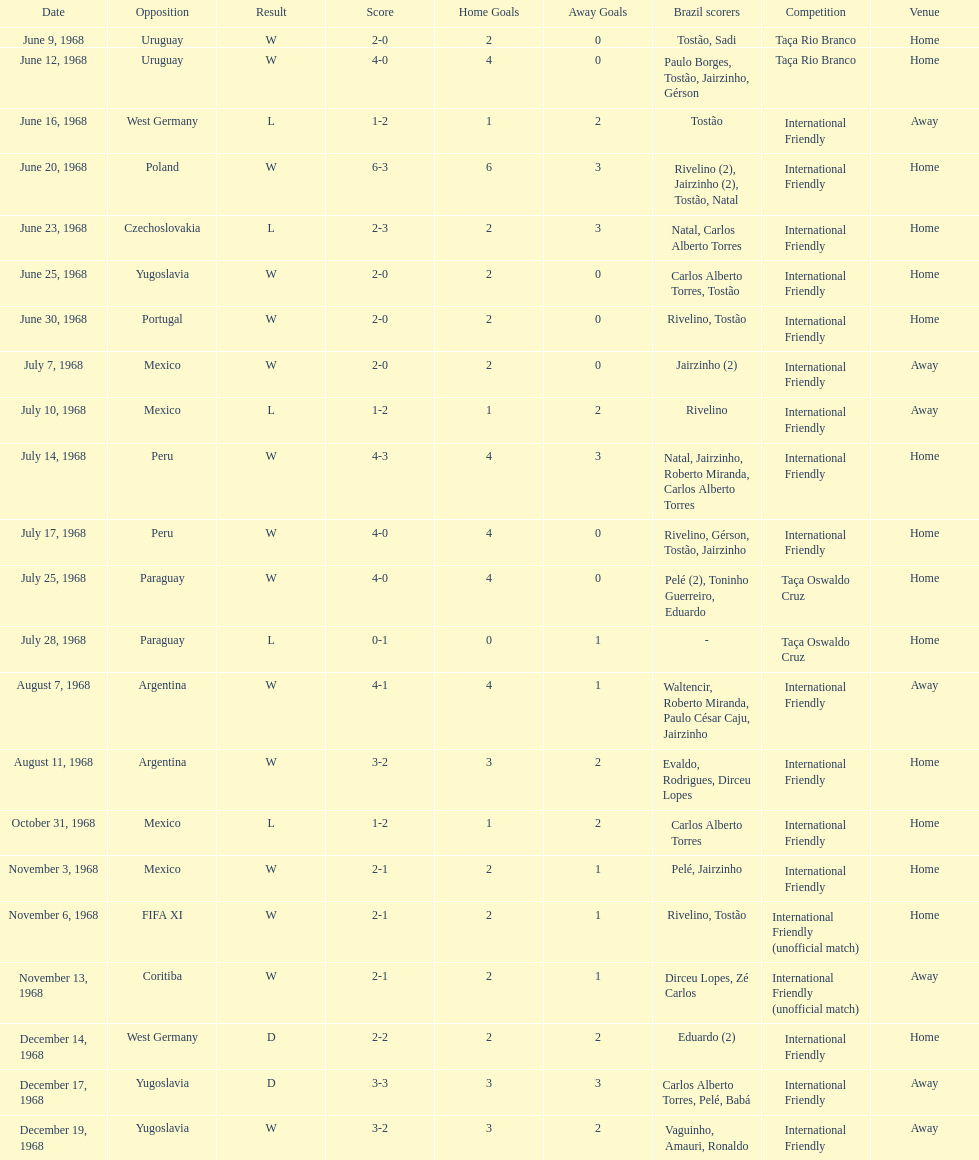The most goals scored by brazil in a game 6. 